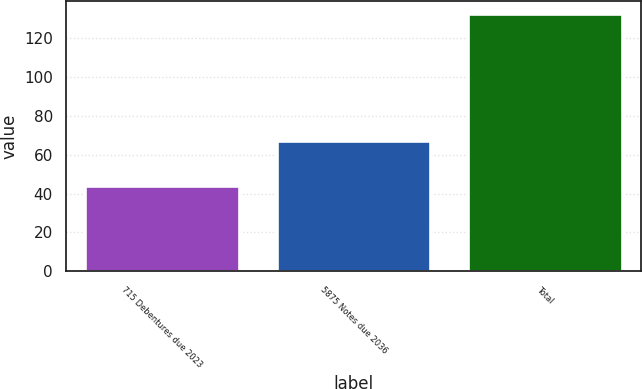Convert chart. <chart><loc_0><loc_0><loc_500><loc_500><bar_chart><fcel>715 Debentures due 2023<fcel>5875 Notes due 2036<fcel>Total<nl><fcel>44<fcel>67<fcel>132<nl></chart> 